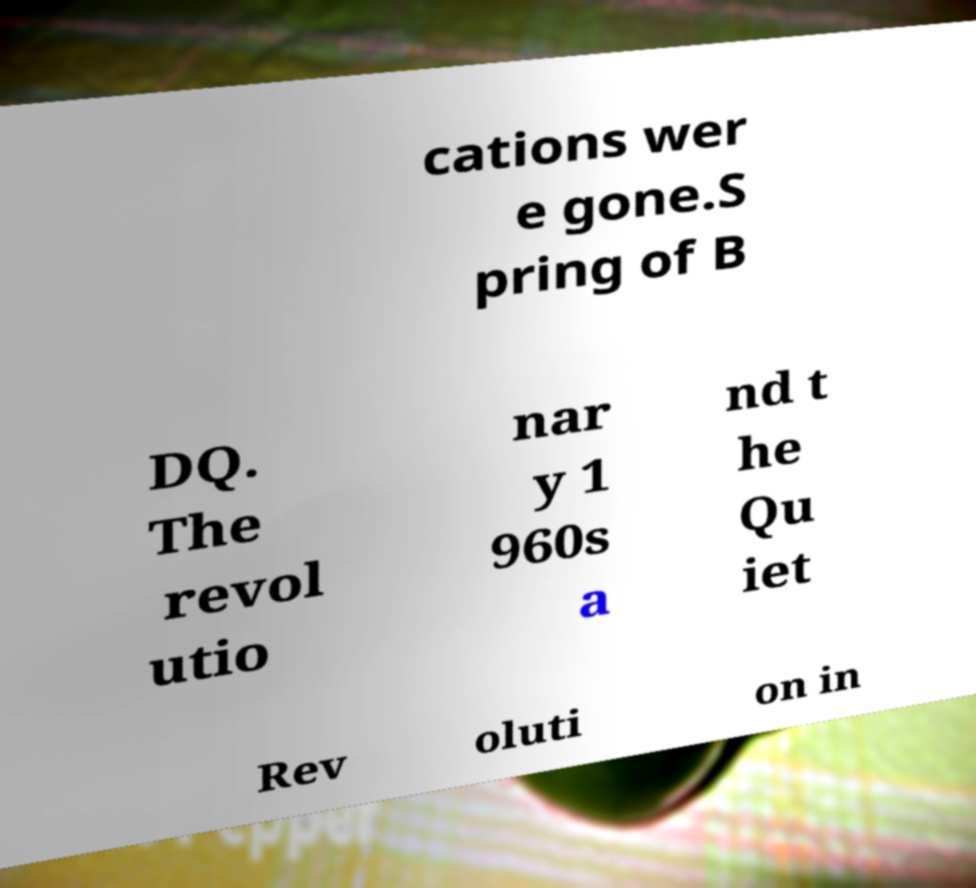I need the written content from this picture converted into text. Can you do that? cations wer e gone.S pring of B DQ. The revol utio nar y 1 960s a nd t he Qu iet Rev oluti on in 